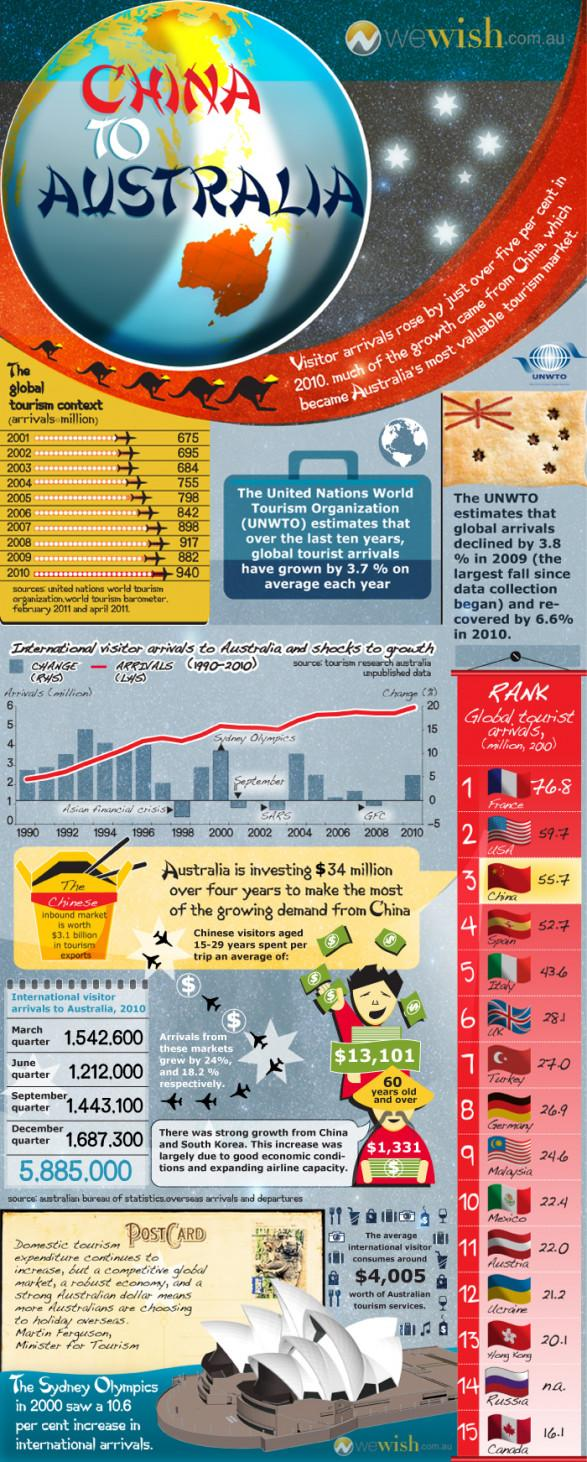Point out several critical features in this image. The increase in international visitor arrivals between 2002 and 2004 was due to the outbreak of SARS. During the June and September quarters, a total of 2,655,100 international visitors came. The number of tourists increased by 265 million from 2001 to 2010. The average amount spent per trip by senior citizens from China is $1,331. In all quarters of 2010, a total of 5,885,000 international visitors visited. 